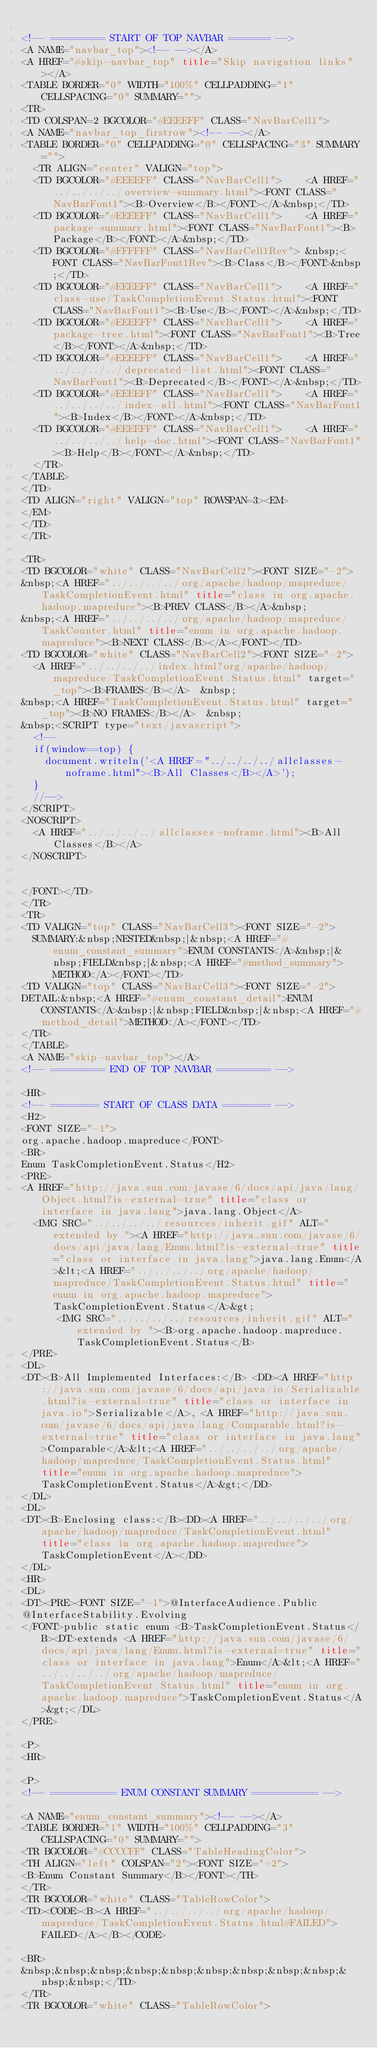<code> <loc_0><loc_0><loc_500><loc_500><_HTML_>
<!-- ========= START OF TOP NAVBAR ======= -->
<A NAME="navbar_top"><!-- --></A>
<A HREF="#skip-navbar_top" title="Skip navigation links"></A>
<TABLE BORDER="0" WIDTH="100%" CELLPADDING="1" CELLSPACING="0" SUMMARY="">
<TR>
<TD COLSPAN=2 BGCOLOR="#EEEEFF" CLASS="NavBarCell1">
<A NAME="navbar_top_firstrow"><!-- --></A>
<TABLE BORDER="0" CELLPADDING="0" CELLSPACING="3" SUMMARY="">
  <TR ALIGN="center" VALIGN="top">
  <TD BGCOLOR="#EEEEFF" CLASS="NavBarCell1">    <A HREF="../../../../overview-summary.html"><FONT CLASS="NavBarFont1"><B>Overview</B></FONT></A>&nbsp;</TD>
  <TD BGCOLOR="#EEEEFF" CLASS="NavBarCell1">    <A HREF="package-summary.html"><FONT CLASS="NavBarFont1"><B>Package</B></FONT></A>&nbsp;</TD>
  <TD BGCOLOR="#FFFFFF" CLASS="NavBarCell1Rev"> &nbsp;<FONT CLASS="NavBarFont1Rev"><B>Class</B></FONT>&nbsp;</TD>
  <TD BGCOLOR="#EEEEFF" CLASS="NavBarCell1">    <A HREF="class-use/TaskCompletionEvent.Status.html"><FONT CLASS="NavBarFont1"><B>Use</B></FONT></A>&nbsp;</TD>
  <TD BGCOLOR="#EEEEFF" CLASS="NavBarCell1">    <A HREF="package-tree.html"><FONT CLASS="NavBarFont1"><B>Tree</B></FONT></A>&nbsp;</TD>
  <TD BGCOLOR="#EEEEFF" CLASS="NavBarCell1">    <A HREF="../../../../deprecated-list.html"><FONT CLASS="NavBarFont1"><B>Deprecated</B></FONT></A>&nbsp;</TD>
  <TD BGCOLOR="#EEEEFF" CLASS="NavBarCell1">    <A HREF="../../../../index-all.html"><FONT CLASS="NavBarFont1"><B>Index</B></FONT></A>&nbsp;</TD>
  <TD BGCOLOR="#EEEEFF" CLASS="NavBarCell1">    <A HREF="../../../../help-doc.html"><FONT CLASS="NavBarFont1"><B>Help</B></FONT></A>&nbsp;</TD>
  </TR>
</TABLE>
</TD>
<TD ALIGN="right" VALIGN="top" ROWSPAN=3><EM>
</EM>
</TD>
</TR>

<TR>
<TD BGCOLOR="white" CLASS="NavBarCell2"><FONT SIZE="-2">
&nbsp;<A HREF="../../../../org/apache/hadoop/mapreduce/TaskCompletionEvent.html" title="class in org.apache.hadoop.mapreduce"><B>PREV CLASS</B></A>&nbsp;
&nbsp;<A HREF="../../../../org/apache/hadoop/mapreduce/TaskCounter.html" title="enum in org.apache.hadoop.mapreduce"><B>NEXT CLASS</B></A></FONT></TD>
<TD BGCOLOR="white" CLASS="NavBarCell2"><FONT SIZE="-2">
  <A HREF="../../../../index.html?org/apache/hadoop/mapreduce/TaskCompletionEvent.Status.html" target="_top"><B>FRAMES</B></A>  &nbsp;
&nbsp;<A HREF="TaskCompletionEvent.Status.html" target="_top"><B>NO FRAMES</B></A>  &nbsp;
&nbsp;<SCRIPT type="text/javascript">
  <!--
  if(window==top) {
    document.writeln('<A HREF="../../../../allclasses-noframe.html"><B>All Classes</B></A>');
  }
  //-->
</SCRIPT>
<NOSCRIPT>
  <A HREF="../../../../allclasses-noframe.html"><B>All Classes</B></A>
</NOSCRIPT>


</FONT></TD>
</TR>
<TR>
<TD VALIGN="top" CLASS="NavBarCell3"><FONT SIZE="-2">
  SUMMARY:&nbsp;NESTED&nbsp;|&nbsp;<A HREF="#enum_constant_summary">ENUM CONSTANTS</A>&nbsp;|&nbsp;FIELD&nbsp;|&nbsp;<A HREF="#method_summary">METHOD</A></FONT></TD>
<TD VALIGN="top" CLASS="NavBarCell3"><FONT SIZE="-2">
DETAIL:&nbsp;<A HREF="#enum_constant_detail">ENUM CONSTANTS</A>&nbsp;|&nbsp;FIELD&nbsp;|&nbsp;<A HREF="#method_detail">METHOD</A></FONT></TD>
</TR>
</TABLE>
<A NAME="skip-navbar_top"></A>
<!-- ========= END OF TOP NAVBAR ========= -->

<HR>
<!-- ======== START OF CLASS DATA ======== -->
<H2>
<FONT SIZE="-1">
org.apache.hadoop.mapreduce</FONT>
<BR>
Enum TaskCompletionEvent.Status</H2>
<PRE>
<A HREF="http://java.sun.com/javase/6/docs/api/java/lang/Object.html?is-external=true" title="class or interface in java.lang">java.lang.Object</A>
  <IMG SRC="../../../../resources/inherit.gif" ALT="extended by "><A HREF="http://java.sun.com/javase/6/docs/api/java/lang/Enum.html?is-external=true" title="class or interface in java.lang">java.lang.Enum</A>&lt;<A HREF="../../../../org/apache/hadoop/mapreduce/TaskCompletionEvent.Status.html" title="enum in org.apache.hadoop.mapreduce">TaskCompletionEvent.Status</A>&gt;
      <IMG SRC="../../../../resources/inherit.gif" ALT="extended by "><B>org.apache.hadoop.mapreduce.TaskCompletionEvent.Status</B>
</PRE>
<DL>
<DT><B>All Implemented Interfaces:</B> <DD><A HREF="http://java.sun.com/javase/6/docs/api/java/io/Serializable.html?is-external=true" title="class or interface in java.io">Serializable</A>, <A HREF="http://java.sun.com/javase/6/docs/api/java/lang/Comparable.html?is-external=true" title="class or interface in java.lang">Comparable</A>&lt;<A HREF="../../../../org/apache/hadoop/mapreduce/TaskCompletionEvent.Status.html" title="enum in org.apache.hadoop.mapreduce">TaskCompletionEvent.Status</A>&gt;</DD>
</DL>
<DL>
<DT><B>Enclosing class:</B><DD><A HREF="../../../../org/apache/hadoop/mapreduce/TaskCompletionEvent.html" title="class in org.apache.hadoop.mapreduce">TaskCompletionEvent</A></DD>
</DL>
<HR>
<DL>
<DT><PRE><FONT SIZE="-1">@InterfaceAudience.Public
@InterfaceStability.Evolving
</FONT>public static enum <B>TaskCompletionEvent.Status</B><DT>extends <A HREF="http://java.sun.com/javase/6/docs/api/java/lang/Enum.html?is-external=true" title="class or interface in java.lang">Enum</A>&lt;<A HREF="../../../../org/apache/hadoop/mapreduce/TaskCompletionEvent.Status.html" title="enum in org.apache.hadoop.mapreduce">TaskCompletionEvent.Status</A>&gt;</DL>
</PRE>

<P>
<HR>

<P>
<!-- =========== ENUM CONSTANT SUMMARY =========== -->

<A NAME="enum_constant_summary"><!-- --></A>
<TABLE BORDER="1" WIDTH="100%" CELLPADDING="3" CELLSPACING="0" SUMMARY="">
<TR BGCOLOR="#CCCCFF" CLASS="TableHeadingColor">
<TH ALIGN="left" COLSPAN="2"><FONT SIZE="+2">
<B>Enum Constant Summary</B></FONT></TH>
</TR>
<TR BGCOLOR="white" CLASS="TableRowColor">
<TD><CODE><B><A HREF="../../../../org/apache/hadoop/mapreduce/TaskCompletionEvent.Status.html#FAILED">FAILED</A></B></CODE>

<BR>
&nbsp;&nbsp;&nbsp;&nbsp;&nbsp;&nbsp;&nbsp;&nbsp;&nbsp;&nbsp;&nbsp;</TD>
</TR>
<TR BGCOLOR="white" CLASS="TableRowColor"></code> 